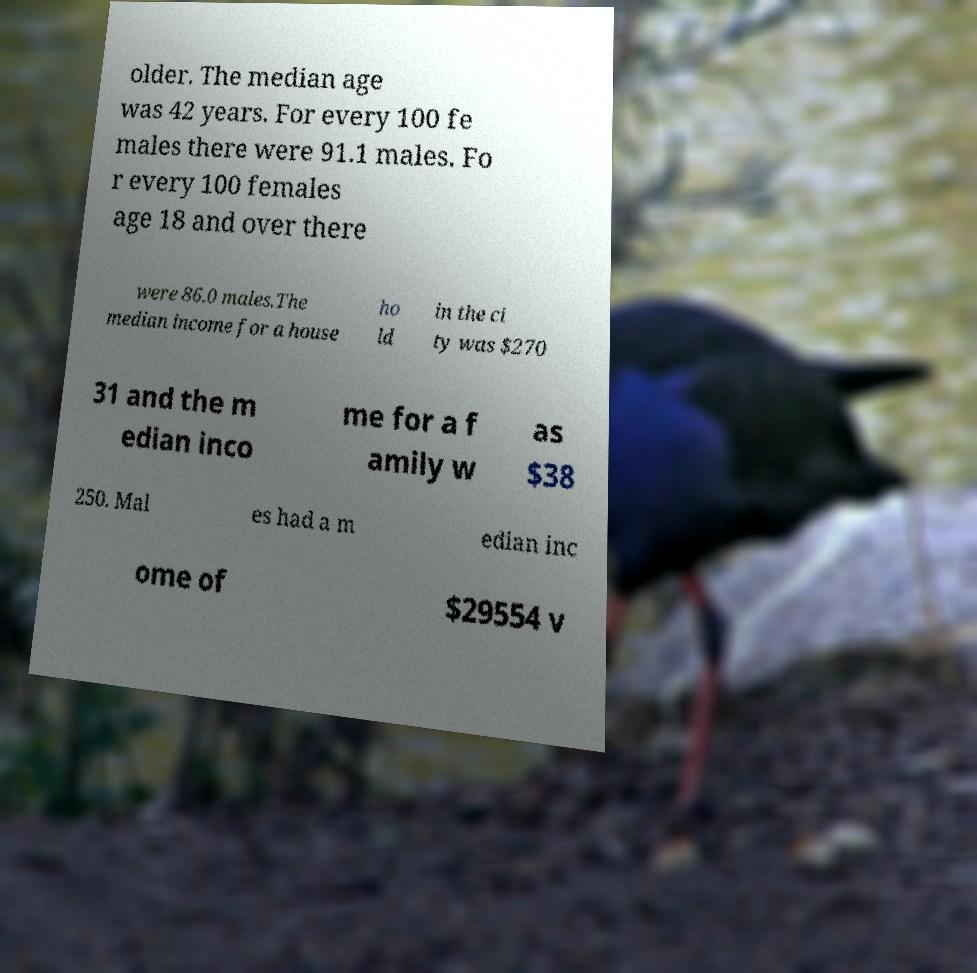There's text embedded in this image that I need extracted. Can you transcribe it verbatim? older. The median age was 42 years. For every 100 fe males there were 91.1 males. Fo r every 100 females age 18 and over there were 86.0 males.The median income for a house ho ld in the ci ty was $270 31 and the m edian inco me for a f amily w as $38 250. Mal es had a m edian inc ome of $29554 v 